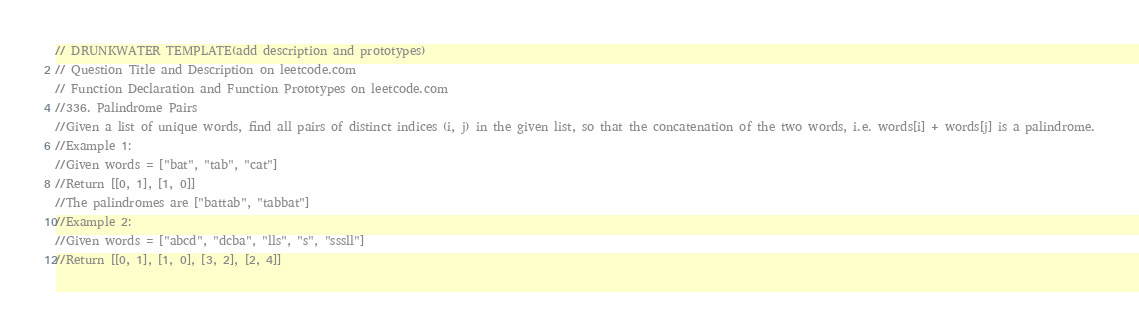Convert code to text. <code><loc_0><loc_0><loc_500><loc_500><_Kotlin_>// DRUNKWATER TEMPLATE(add description and prototypes)
// Question Title and Description on leetcode.com
// Function Declaration and Function Prototypes on leetcode.com
//336. Palindrome Pairs
//Given a list of unique words, find all pairs of distinct indices (i, j) in the given list, so that the concatenation of the two words, i.e. words[i] + words[j] is a palindrome.
//Example 1:
//Given words = ["bat", "tab", "cat"]
//Return [[0, 1], [1, 0]]
//The palindromes are ["battab", "tabbat"]
//Example 2:
//Given words = ["abcd", "dcba", "lls", "s", "sssll"]
//Return [[0, 1], [1, 0], [3, 2], [2, 4]]</code> 